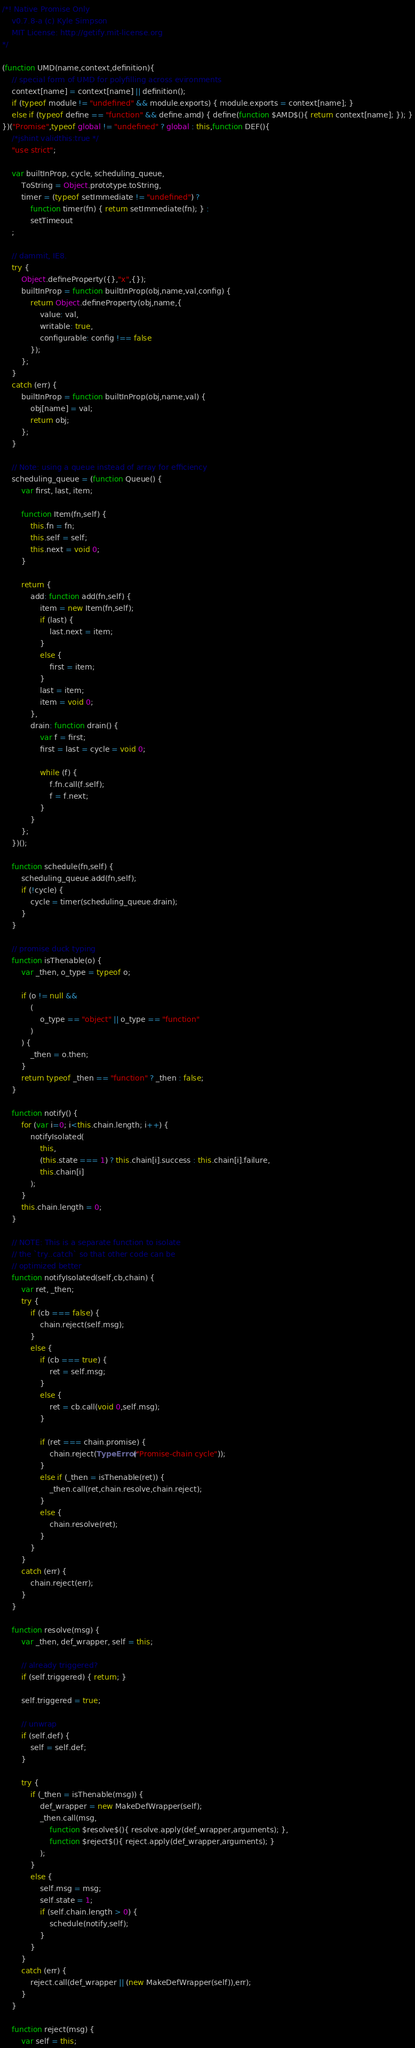<code> <loc_0><loc_0><loc_500><loc_500><_JavaScript_>/*! Native Promise Only
    v0.7.8-a (c) Kyle Simpson
    MIT License: http://getify.mit-license.org
*/

(function UMD(name,context,definition){
	// special form of UMD for polyfilling across evironments
	context[name] = context[name] || definition();
	if (typeof module != "undefined" && module.exports) { module.exports = context[name]; }
	else if (typeof define == "function" && define.amd) { define(function $AMD$(){ return context[name]; }); }
})("Promise",typeof global != "undefined" ? global : this,function DEF(){
	/*jshint validthis:true */
	"use strict";

	var builtInProp, cycle, scheduling_queue,
		ToString = Object.prototype.toString,
		timer = (typeof setImmediate != "undefined") ?
			function timer(fn) { return setImmediate(fn); } :
			setTimeout
	;

	// dammit, IE8.
	try {
		Object.defineProperty({},"x",{});
		builtInProp = function builtInProp(obj,name,val,config) {
			return Object.defineProperty(obj,name,{
				value: val,
				writable: true,
				configurable: config !== false
			});
		};
	}
	catch (err) {
		builtInProp = function builtInProp(obj,name,val) {
			obj[name] = val;
			return obj;
		};
	}

	// Note: using a queue instead of array for efficiency
	scheduling_queue = (function Queue() {
		var first, last, item;

		function Item(fn,self) {
			this.fn = fn;
			this.self = self;
			this.next = void 0;
		}

		return {
			add: function add(fn,self) {
				item = new Item(fn,self);
				if (last) {
					last.next = item;
				}
				else {
					first = item;
				}
				last = item;
				item = void 0;
			},
			drain: function drain() {
				var f = first;
				first = last = cycle = void 0;

				while (f) {
					f.fn.call(f.self);
					f = f.next;
				}
			}
		};
	})();

	function schedule(fn,self) {
		scheduling_queue.add(fn,self);
		if (!cycle) {
			cycle = timer(scheduling_queue.drain);
		}
	}

	// promise duck typing
	function isThenable(o) {
		var _then, o_type = typeof o;

		if (o != null &&
			(
				o_type == "object" || o_type == "function"
			)
		) {
			_then = o.then;
		}
		return typeof _then == "function" ? _then : false;
	}

	function notify() {
		for (var i=0; i<this.chain.length; i++) {
			notifyIsolated(
				this,
				(this.state === 1) ? this.chain[i].success : this.chain[i].failure,
				this.chain[i]
			);
		}
		this.chain.length = 0;
	}

	// NOTE: This is a separate function to isolate
	// the `try..catch` so that other code can be
	// optimized better
	function notifyIsolated(self,cb,chain) {
		var ret, _then;
		try {
			if (cb === false) {
				chain.reject(self.msg);
			}
			else {
				if (cb === true) {
					ret = self.msg;
				}
				else {
					ret = cb.call(void 0,self.msg);
				}

				if (ret === chain.promise) {
					chain.reject(TypeError("Promise-chain cycle"));
				}
				else if (_then = isThenable(ret)) {
					_then.call(ret,chain.resolve,chain.reject);
				}
				else {
					chain.resolve(ret);
				}
			}
		}
		catch (err) {
			chain.reject(err);
		}
	}

	function resolve(msg) {
		var _then, def_wrapper, self = this;

		// already triggered?
		if (self.triggered) { return; }

		self.triggered = true;

		// unwrap
		if (self.def) {
			self = self.def;
		}

		try {
			if (_then = isThenable(msg)) {
				def_wrapper = new MakeDefWrapper(self);
				_then.call(msg,
					function $resolve$(){ resolve.apply(def_wrapper,arguments); },
					function $reject$(){ reject.apply(def_wrapper,arguments); }
				);
			}
			else {
				self.msg = msg;
				self.state = 1;
				if (self.chain.length > 0) {
					schedule(notify,self);
				}
			}
		}
		catch (err) {
			reject.call(def_wrapper || (new MakeDefWrapper(self)),err);
		}
	}

	function reject(msg) {
		var self = this;
</code> 